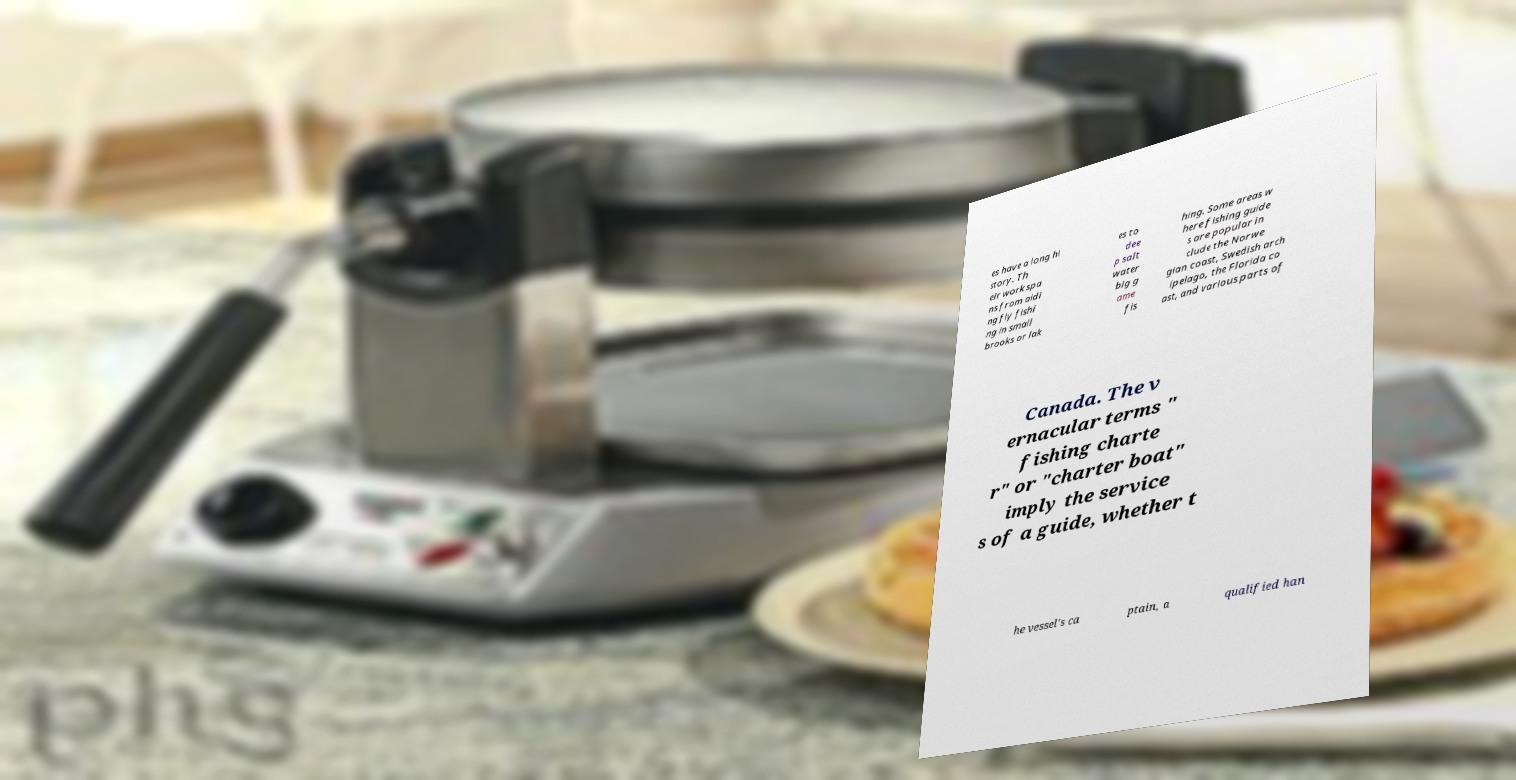For documentation purposes, I need the text within this image transcribed. Could you provide that? es have a long hi story. Th eir work spa ns from aidi ng fly fishi ng in small brooks or lak es to dee p salt water big g ame fis hing. Some areas w here fishing guide s are popular in clude the Norwe gian coast, Swedish arch ipelago, the Florida co ast, and various parts of Canada. The v ernacular terms " fishing charte r" or "charter boat" imply the service s of a guide, whether t he vessel's ca ptain, a qualified han 